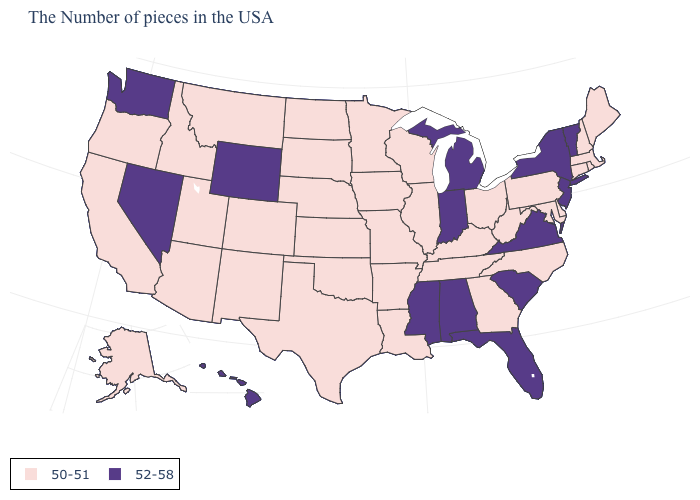Name the states that have a value in the range 52-58?
Answer briefly. Vermont, New York, New Jersey, Virginia, South Carolina, Florida, Michigan, Indiana, Alabama, Mississippi, Wyoming, Nevada, Washington, Hawaii. What is the value of Kansas?
Quick response, please. 50-51. What is the lowest value in the USA?
Short answer required. 50-51. What is the value of Virginia?
Keep it brief. 52-58. Does the first symbol in the legend represent the smallest category?
Keep it brief. Yes. Which states hav the highest value in the MidWest?
Concise answer only. Michigan, Indiana. Does South Dakota have a lower value than South Carolina?
Answer briefly. Yes. Does Delaware have the highest value in the USA?
Give a very brief answer. No. Name the states that have a value in the range 50-51?
Short answer required. Maine, Massachusetts, Rhode Island, New Hampshire, Connecticut, Delaware, Maryland, Pennsylvania, North Carolina, West Virginia, Ohio, Georgia, Kentucky, Tennessee, Wisconsin, Illinois, Louisiana, Missouri, Arkansas, Minnesota, Iowa, Kansas, Nebraska, Oklahoma, Texas, South Dakota, North Dakota, Colorado, New Mexico, Utah, Montana, Arizona, Idaho, California, Oregon, Alaska. Among the states that border Alabama , which have the lowest value?
Be succinct. Georgia, Tennessee. Name the states that have a value in the range 52-58?
Quick response, please. Vermont, New York, New Jersey, Virginia, South Carolina, Florida, Michigan, Indiana, Alabama, Mississippi, Wyoming, Nevada, Washington, Hawaii. How many symbols are there in the legend?
Keep it brief. 2. What is the lowest value in the USA?
Quick response, please. 50-51. What is the value of New York?
Give a very brief answer. 52-58. 